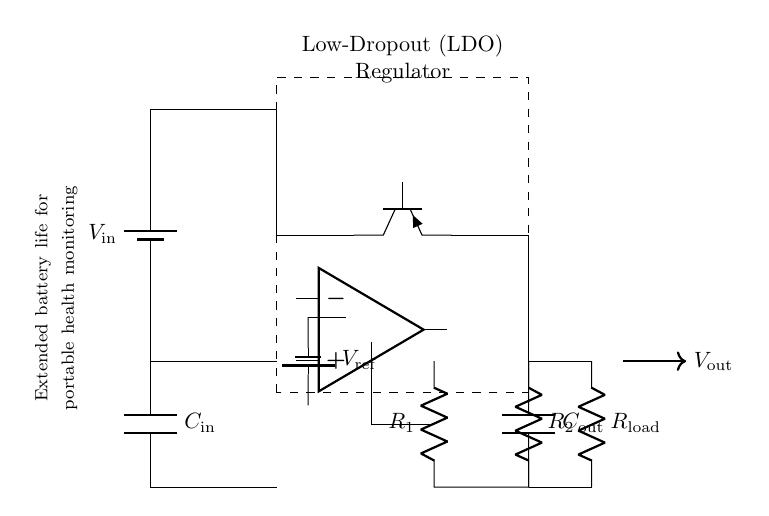What kind of regulator is shown in this circuit? The circuit diagram includes a Low-Dropout Regulator, indicated by the labeling within the dashed rectangle surrounding the main component.
Answer: Low-Dropout Regulator What is the purpose of the input capacitor in this circuit? The input capacitor helps stabilize the input voltage and filter out noise from the battery, ensuring steady voltage is supplied to the regulator. This is essential in portable health monitoring applications to maintain accuracy.
Answer: Stabilization What are the values of the resistors in the feedback network? The circuit shows two resistors labeled R1 and R2, but their values are not explicitly specified. However, they are crucial for setting the output voltage by creating a voltage divider connected to the error amplifier.
Answer: R1 and R2 What voltage source is provided for the reference voltage? The reference voltage is supplied by a battery, denoted as Vref. It is critical for the operation of the error amplifier, maintaining the desired output voltage despite variations in input voltage or load.
Answer: Vref How does this Low-Dropout Regulator help extend battery life? The low dropout characteristic means that the regulator can provide a stable output voltage with a minimal difference between input and output voltage. This efficient operation reduces power loss and helps to prolong the battery's operational life, especially important in portable devices.
Answer: Extended battery life What is the load component in this circuit? The load is represented by a resistor labeled Rload. It absorbs the output current from the regulator, making it an essential part of the overall circuit performance in supplying the monitored health data.
Answer: Rload What is the function of the error amplifier in this circuit? The error amplifier compares the output voltage with the reference voltage, adjusting the pass transistor's operation to maintain a stable output despite any changes in load or input voltage. This feedback loop is crucial for accuracy in health monitoring systems.
Answer: Voltage regulation 